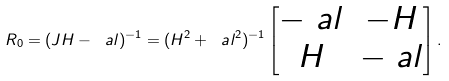Convert formula to latex. <formula><loc_0><loc_0><loc_500><loc_500>R _ { 0 } = ( J H - \ a l ) ^ { - 1 } = ( H ^ { 2 } + \ a l ^ { 2 } ) ^ { - 1 } \begin{bmatrix} - \ a l & - H \\ H & - \ a l \end{bmatrix} .</formula> 